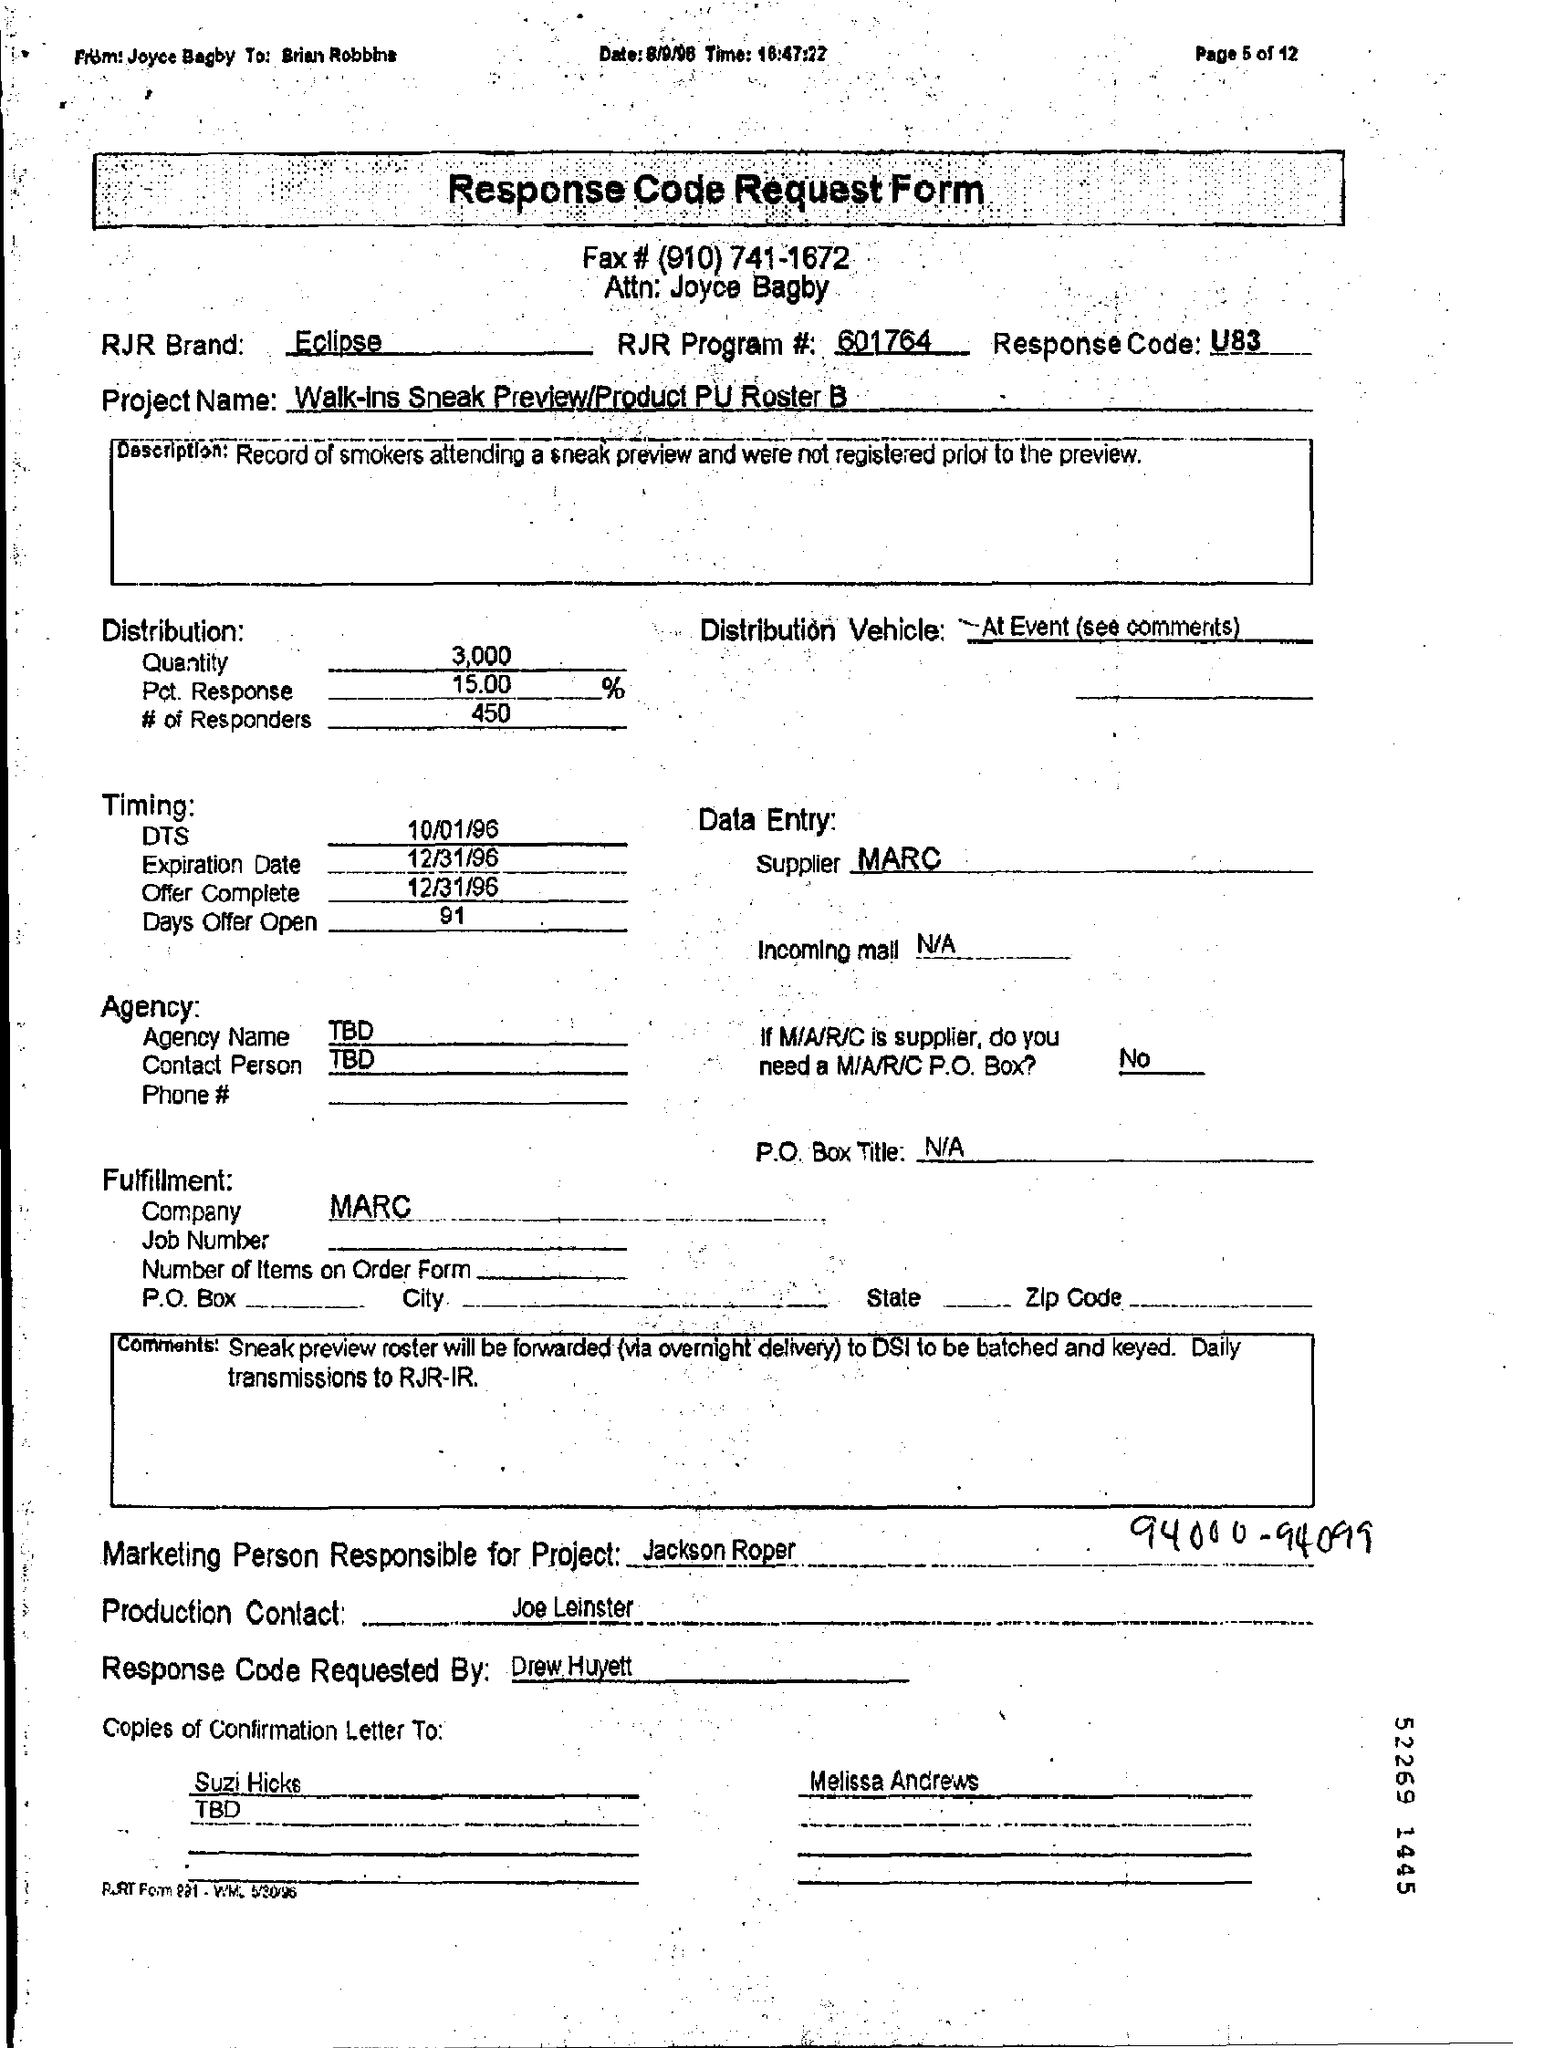Specify some key components in this picture. The response code is U83.. The RJR Program Number is 601764... The Letter Head contains information written in the Request Code Response Form. The information entered in the Distribution Vehicle Field at the specified event is documented. The expiration date is December 31, 1996. 